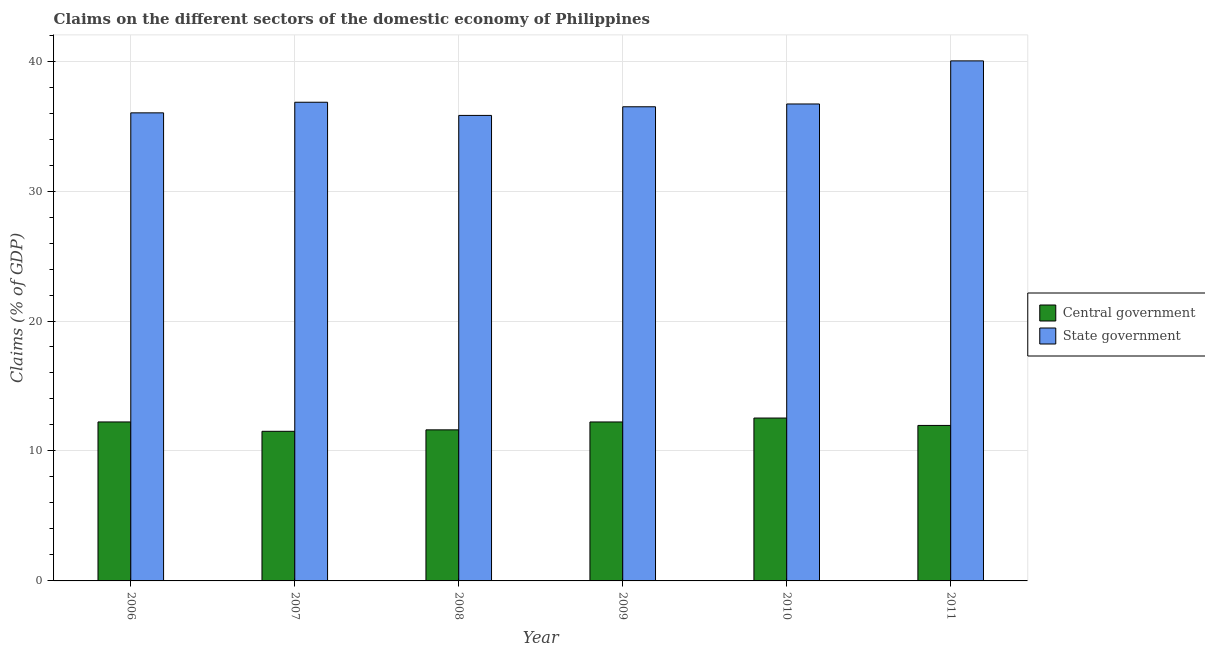How many different coloured bars are there?
Your answer should be compact. 2. Are the number of bars per tick equal to the number of legend labels?
Provide a short and direct response. Yes. Are the number of bars on each tick of the X-axis equal?
Offer a very short reply. Yes. What is the claims on central government in 2009?
Make the answer very short. 12.23. Across all years, what is the maximum claims on central government?
Offer a very short reply. 12.53. Across all years, what is the minimum claims on central government?
Keep it short and to the point. 11.51. In which year was the claims on state government maximum?
Your answer should be very brief. 2011. What is the total claims on central government in the graph?
Make the answer very short. 72.1. What is the difference between the claims on central government in 2006 and that in 2007?
Your response must be concise. 0.72. What is the difference between the claims on state government in 2011 and the claims on central government in 2010?
Keep it short and to the point. 3.32. What is the average claims on state government per year?
Provide a short and direct response. 36.98. In the year 2010, what is the difference between the claims on state government and claims on central government?
Give a very brief answer. 0. In how many years, is the claims on central government greater than 40 %?
Keep it short and to the point. 0. What is the ratio of the claims on central government in 2006 to that in 2009?
Provide a short and direct response. 1. Is the difference between the claims on state government in 2010 and 2011 greater than the difference between the claims on central government in 2010 and 2011?
Your response must be concise. No. What is the difference between the highest and the second highest claims on state government?
Provide a succinct answer. 3.18. What is the difference between the highest and the lowest claims on state government?
Keep it short and to the point. 4.2. Is the sum of the claims on state government in 2006 and 2008 greater than the maximum claims on central government across all years?
Provide a short and direct response. Yes. What does the 1st bar from the left in 2008 represents?
Provide a short and direct response. Central government. What does the 2nd bar from the right in 2008 represents?
Offer a terse response. Central government. Does the graph contain grids?
Provide a succinct answer. Yes. Where does the legend appear in the graph?
Ensure brevity in your answer.  Center right. What is the title of the graph?
Keep it short and to the point. Claims on the different sectors of the domestic economy of Philippines. What is the label or title of the Y-axis?
Give a very brief answer. Claims (% of GDP). What is the Claims (% of GDP) in Central government in 2006?
Give a very brief answer. 12.23. What is the Claims (% of GDP) in State government in 2006?
Provide a short and direct response. 36.02. What is the Claims (% of GDP) in Central government in 2007?
Your response must be concise. 11.51. What is the Claims (% of GDP) in State government in 2007?
Offer a very short reply. 36.83. What is the Claims (% of GDP) of Central government in 2008?
Make the answer very short. 11.62. What is the Claims (% of GDP) in State government in 2008?
Keep it short and to the point. 35.82. What is the Claims (% of GDP) in Central government in 2009?
Make the answer very short. 12.23. What is the Claims (% of GDP) of State government in 2009?
Your answer should be compact. 36.48. What is the Claims (% of GDP) of Central government in 2010?
Keep it short and to the point. 12.53. What is the Claims (% of GDP) of State government in 2010?
Offer a very short reply. 36.7. What is the Claims (% of GDP) of Central government in 2011?
Offer a very short reply. 11.96. What is the Claims (% of GDP) in State government in 2011?
Make the answer very short. 40.02. Across all years, what is the maximum Claims (% of GDP) of Central government?
Provide a succinct answer. 12.53. Across all years, what is the maximum Claims (% of GDP) in State government?
Ensure brevity in your answer.  40.02. Across all years, what is the minimum Claims (% of GDP) of Central government?
Offer a terse response. 11.51. Across all years, what is the minimum Claims (% of GDP) of State government?
Ensure brevity in your answer.  35.82. What is the total Claims (% of GDP) of Central government in the graph?
Keep it short and to the point. 72.1. What is the total Claims (% of GDP) in State government in the graph?
Your response must be concise. 221.87. What is the difference between the Claims (% of GDP) of Central government in 2006 and that in 2007?
Keep it short and to the point. 0.72. What is the difference between the Claims (% of GDP) in State government in 2006 and that in 2007?
Offer a very short reply. -0.82. What is the difference between the Claims (% of GDP) of Central government in 2006 and that in 2008?
Make the answer very short. 0.61. What is the difference between the Claims (% of GDP) of State government in 2006 and that in 2008?
Provide a succinct answer. 0.2. What is the difference between the Claims (% of GDP) of Central government in 2006 and that in 2009?
Your answer should be very brief. 0. What is the difference between the Claims (% of GDP) of State government in 2006 and that in 2009?
Ensure brevity in your answer.  -0.47. What is the difference between the Claims (% of GDP) of Central government in 2006 and that in 2010?
Make the answer very short. -0.3. What is the difference between the Claims (% of GDP) of State government in 2006 and that in 2010?
Keep it short and to the point. -0.68. What is the difference between the Claims (% of GDP) of Central government in 2006 and that in 2011?
Offer a very short reply. 0.27. What is the difference between the Claims (% of GDP) in State government in 2006 and that in 2011?
Your answer should be compact. -4. What is the difference between the Claims (% of GDP) in Central government in 2007 and that in 2008?
Ensure brevity in your answer.  -0.11. What is the difference between the Claims (% of GDP) in State government in 2007 and that in 2008?
Give a very brief answer. 1.01. What is the difference between the Claims (% of GDP) in Central government in 2007 and that in 2009?
Provide a succinct answer. -0.72. What is the difference between the Claims (% of GDP) in State government in 2007 and that in 2009?
Provide a succinct answer. 0.35. What is the difference between the Claims (% of GDP) in Central government in 2007 and that in 2010?
Give a very brief answer. -1.02. What is the difference between the Claims (% of GDP) of State government in 2007 and that in 2010?
Your answer should be very brief. 0.13. What is the difference between the Claims (% of GDP) in Central government in 2007 and that in 2011?
Offer a very short reply. -0.45. What is the difference between the Claims (% of GDP) of State government in 2007 and that in 2011?
Your answer should be very brief. -3.18. What is the difference between the Claims (% of GDP) of Central government in 2008 and that in 2009?
Make the answer very short. -0.61. What is the difference between the Claims (% of GDP) of State government in 2008 and that in 2009?
Offer a terse response. -0.66. What is the difference between the Claims (% of GDP) of Central government in 2008 and that in 2010?
Give a very brief answer. -0.91. What is the difference between the Claims (% of GDP) in State government in 2008 and that in 2010?
Provide a short and direct response. -0.88. What is the difference between the Claims (% of GDP) in Central government in 2008 and that in 2011?
Make the answer very short. -0.34. What is the difference between the Claims (% of GDP) of State government in 2008 and that in 2011?
Your answer should be compact. -4.2. What is the difference between the Claims (% of GDP) of Central government in 2009 and that in 2010?
Your answer should be compact. -0.3. What is the difference between the Claims (% of GDP) in State government in 2009 and that in 2010?
Provide a succinct answer. -0.22. What is the difference between the Claims (% of GDP) of Central government in 2009 and that in 2011?
Give a very brief answer. 0.27. What is the difference between the Claims (% of GDP) in State government in 2009 and that in 2011?
Make the answer very short. -3.53. What is the difference between the Claims (% of GDP) in Central government in 2010 and that in 2011?
Your answer should be compact. 0.57. What is the difference between the Claims (% of GDP) in State government in 2010 and that in 2011?
Your answer should be compact. -3.32. What is the difference between the Claims (% of GDP) in Central government in 2006 and the Claims (% of GDP) in State government in 2007?
Ensure brevity in your answer.  -24.6. What is the difference between the Claims (% of GDP) in Central government in 2006 and the Claims (% of GDP) in State government in 2008?
Provide a short and direct response. -23.59. What is the difference between the Claims (% of GDP) of Central government in 2006 and the Claims (% of GDP) of State government in 2009?
Provide a short and direct response. -24.25. What is the difference between the Claims (% of GDP) in Central government in 2006 and the Claims (% of GDP) in State government in 2010?
Your response must be concise. -24.47. What is the difference between the Claims (% of GDP) of Central government in 2006 and the Claims (% of GDP) of State government in 2011?
Ensure brevity in your answer.  -27.78. What is the difference between the Claims (% of GDP) in Central government in 2007 and the Claims (% of GDP) in State government in 2008?
Your answer should be very brief. -24.31. What is the difference between the Claims (% of GDP) of Central government in 2007 and the Claims (% of GDP) of State government in 2009?
Ensure brevity in your answer.  -24.97. What is the difference between the Claims (% of GDP) of Central government in 2007 and the Claims (% of GDP) of State government in 2010?
Your answer should be compact. -25.19. What is the difference between the Claims (% of GDP) in Central government in 2007 and the Claims (% of GDP) in State government in 2011?
Your response must be concise. -28.5. What is the difference between the Claims (% of GDP) of Central government in 2008 and the Claims (% of GDP) of State government in 2009?
Your answer should be compact. -24.86. What is the difference between the Claims (% of GDP) in Central government in 2008 and the Claims (% of GDP) in State government in 2010?
Offer a terse response. -25.07. What is the difference between the Claims (% of GDP) in Central government in 2008 and the Claims (% of GDP) in State government in 2011?
Give a very brief answer. -28.39. What is the difference between the Claims (% of GDP) in Central government in 2009 and the Claims (% of GDP) in State government in 2010?
Offer a very short reply. -24.47. What is the difference between the Claims (% of GDP) of Central government in 2009 and the Claims (% of GDP) of State government in 2011?
Offer a terse response. -27.78. What is the difference between the Claims (% of GDP) in Central government in 2010 and the Claims (% of GDP) in State government in 2011?
Offer a very short reply. -27.48. What is the average Claims (% of GDP) in Central government per year?
Offer a very short reply. 12.02. What is the average Claims (% of GDP) of State government per year?
Your response must be concise. 36.98. In the year 2006, what is the difference between the Claims (% of GDP) of Central government and Claims (% of GDP) of State government?
Provide a short and direct response. -23.78. In the year 2007, what is the difference between the Claims (% of GDP) of Central government and Claims (% of GDP) of State government?
Your answer should be very brief. -25.32. In the year 2008, what is the difference between the Claims (% of GDP) of Central government and Claims (% of GDP) of State government?
Your response must be concise. -24.2. In the year 2009, what is the difference between the Claims (% of GDP) of Central government and Claims (% of GDP) of State government?
Make the answer very short. -24.25. In the year 2010, what is the difference between the Claims (% of GDP) of Central government and Claims (% of GDP) of State government?
Your answer should be very brief. -24.17. In the year 2011, what is the difference between the Claims (% of GDP) of Central government and Claims (% of GDP) of State government?
Provide a short and direct response. -28.05. What is the ratio of the Claims (% of GDP) of Central government in 2006 to that in 2007?
Give a very brief answer. 1.06. What is the ratio of the Claims (% of GDP) of State government in 2006 to that in 2007?
Provide a short and direct response. 0.98. What is the ratio of the Claims (% of GDP) of Central government in 2006 to that in 2008?
Provide a succinct answer. 1.05. What is the ratio of the Claims (% of GDP) of State government in 2006 to that in 2008?
Provide a short and direct response. 1.01. What is the ratio of the Claims (% of GDP) in State government in 2006 to that in 2009?
Your answer should be very brief. 0.99. What is the ratio of the Claims (% of GDP) in State government in 2006 to that in 2010?
Keep it short and to the point. 0.98. What is the ratio of the Claims (% of GDP) of Central government in 2006 to that in 2011?
Make the answer very short. 1.02. What is the ratio of the Claims (% of GDP) in State government in 2007 to that in 2008?
Ensure brevity in your answer.  1.03. What is the ratio of the Claims (% of GDP) in Central government in 2007 to that in 2009?
Your response must be concise. 0.94. What is the ratio of the Claims (% of GDP) of State government in 2007 to that in 2009?
Offer a very short reply. 1.01. What is the ratio of the Claims (% of GDP) in Central government in 2007 to that in 2010?
Your response must be concise. 0.92. What is the ratio of the Claims (% of GDP) of State government in 2007 to that in 2010?
Your response must be concise. 1. What is the ratio of the Claims (% of GDP) in Central government in 2007 to that in 2011?
Your answer should be compact. 0.96. What is the ratio of the Claims (% of GDP) in State government in 2007 to that in 2011?
Give a very brief answer. 0.92. What is the ratio of the Claims (% of GDP) in Central government in 2008 to that in 2009?
Your response must be concise. 0.95. What is the ratio of the Claims (% of GDP) of State government in 2008 to that in 2009?
Provide a succinct answer. 0.98. What is the ratio of the Claims (% of GDP) in Central government in 2008 to that in 2010?
Keep it short and to the point. 0.93. What is the ratio of the Claims (% of GDP) of Central government in 2008 to that in 2011?
Offer a terse response. 0.97. What is the ratio of the Claims (% of GDP) in State government in 2008 to that in 2011?
Offer a terse response. 0.9. What is the ratio of the Claims (% of GDP) in Central government in 2009 to that in 2010?
Provide a succinct answer. 0.98. What is the ratio of the Claims (% of GDP) in State government in 2009 to that in 2010?
Provide a short and direct response. 0.99. What is the ratio of the Claims (% of GDP) in Central government in 2009 to that in 2011?
Give a very brief answer. 1.02. What is the ratio of the Claims (% of GDP) of State government in 2009 to that in 2011?
Offer a very short reply. 0.91. What is the ratio of the Claims (% of GDP) of Central government in 2010 to that in 2011?
Your answer should be very brief. 1.05. What is the ratio of the Claims (% of GDP) in State government in 2010 to that in 2011?
Offer a terse response. 0.92. What is the difference between the highest and the second highest Claims (% of GDP) of Central government?
Your response must be concise. 0.3. What is the difference between the highest and the second highest Claims (% of GDP) in State government?
Offer a terse response. 3.18. What is the difference between the highest and the lowest Claims (% of GDP) of Central government?
Ensure brevity in your answer.  1.02. What is the difference between the highest and the lowest Claims (% of GDP) in State government?
Provide a short and direct response. 4.2. 